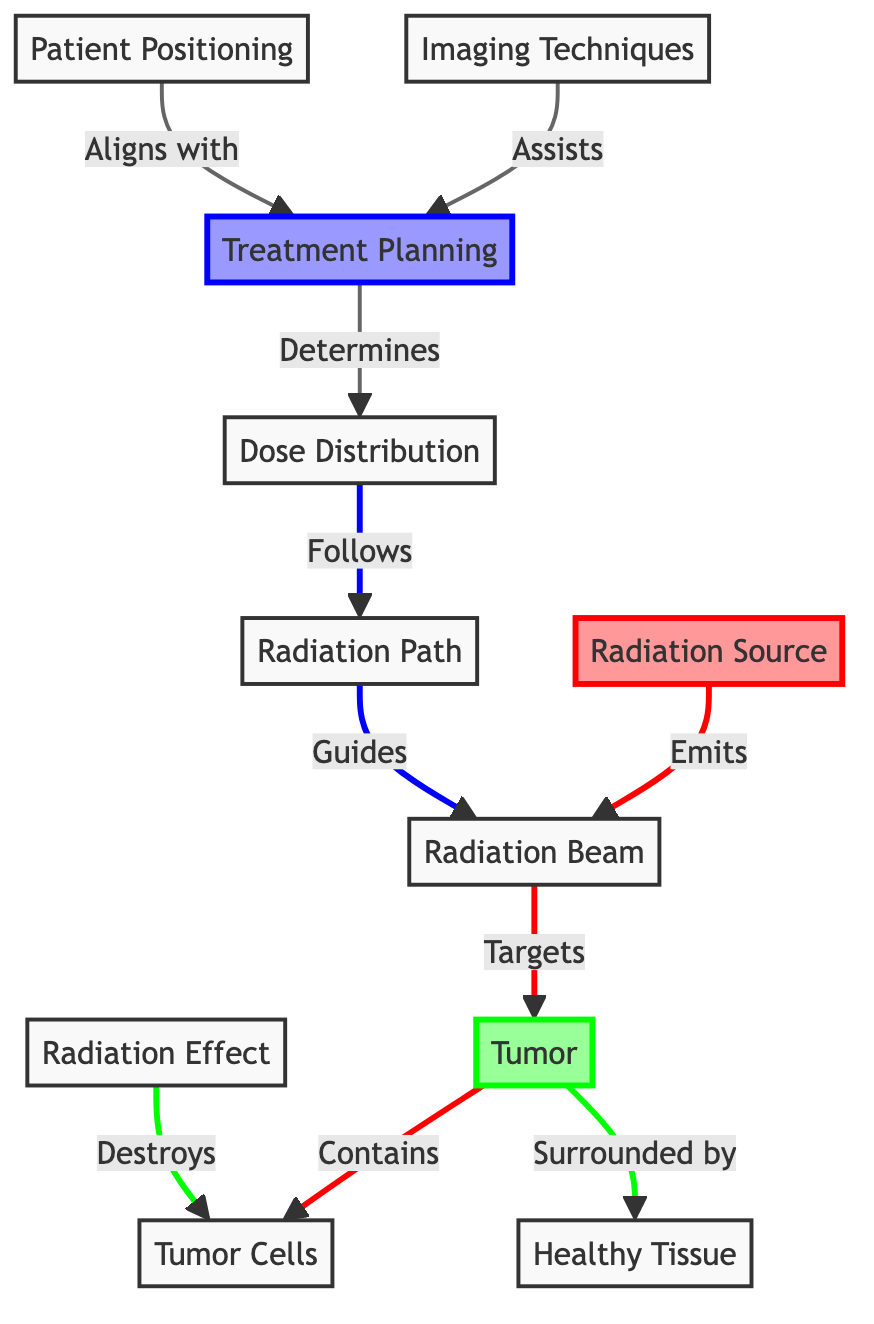What is the primary source of radiation in the diagram? The diagram explicitly labels "Radiation Source" as the starting point. This is a direct identification from the diagram's content.
Answer: Radiation Source How many processes are represented in the diagram? The diagram contains three distinct processes: Treatment Planning, Patient Positioning, and Radiation Effect. Counting the unique labeled processes leads to the answer.
Answer: 3 What surrounds the tumor in the diagram? The diagram states that the tumor is "Surrounded by" healthy tissue, indicating the direct relationship between these two components.
Answer: Healthy Tissue What role do imaging techniques play in the process? The diagram indicates that imaging techniques "Assists" treatment planning, showing their functional relationship and role within the overall process of radiation therapy.
Answer: Assists Which specifically identified cells are being targeted by the radiation? The diagram indicates that the tumor "Contains" tumor cells, clarifying that such cells are the direct targets of the radiation treatment.
Answer: Tumor Cells How does the radiation beam interact with the tumor? According to the diagram, the radiation beam "Targets" the tumor, establishing a direct action and intention of the therapy.
Answer: Targets What influences the dose distribution in radiation therapy? The diagram shows that treatment planning "Determines" the dose distribution, explaining the foundational influence of planning in the therapy process.
Answer: Determines In what way does patient positioning relate to treatment planning? The diagram describes patient positioning as aligning "with" treatment planning, highlighting the connection and importance of accurately positioning the patient during therapy sessions.
Answer: Aligns with Which aspect of treatment planning is assisted by imaging techniques? The diagram implies that imaging techniques aid in the "Treatment Planning," suggesting they contribute to developing an effective therapy strategy.
Answer: Treatment Planning 